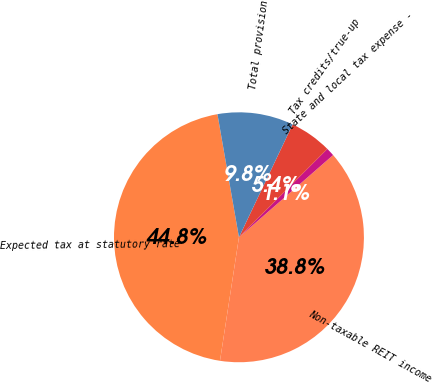Convert chart. <chart><loc_0><loc_0><loc_500><loc_500><pie_chart><fcel>Expected tax at statutory rate<fcel>Non-taxable REIT income<fcel>State and local tax expense -<fcel>Tax credits/true-up<fcel>Total provision<nl><fcel>44.82%<fcel>38.85%<fcel>1.07%<fcel>5.44%<fcel>9.82%<nl></chart> 